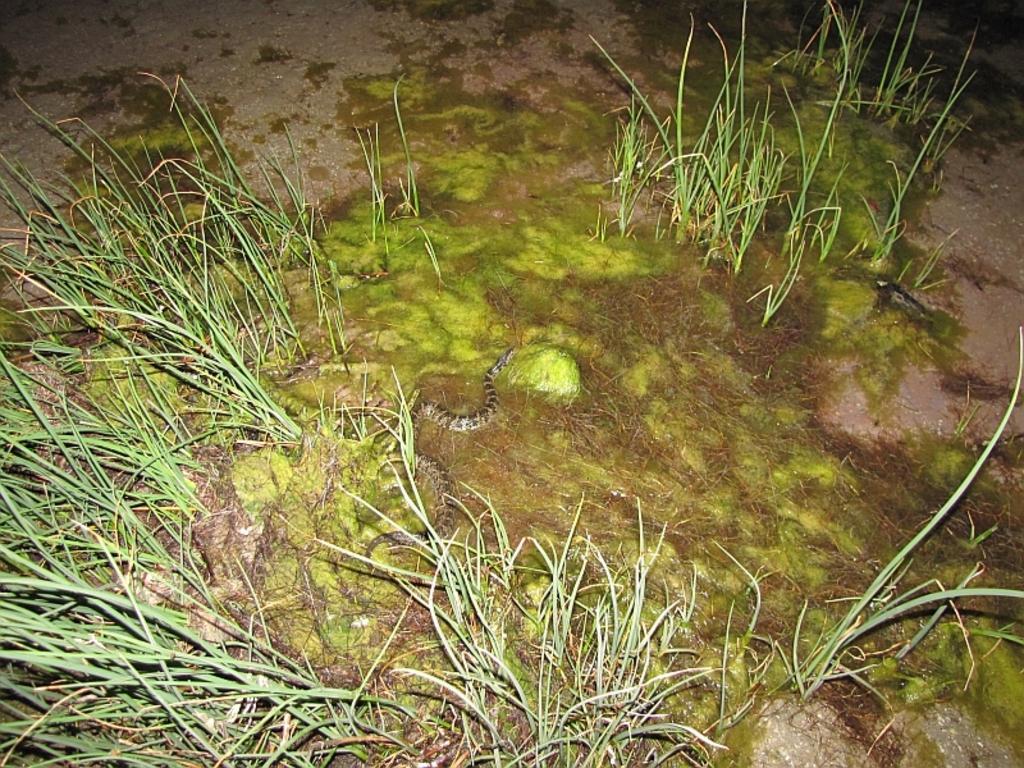Please provide a concise description of this image. In this image there is a snake in the grass. 